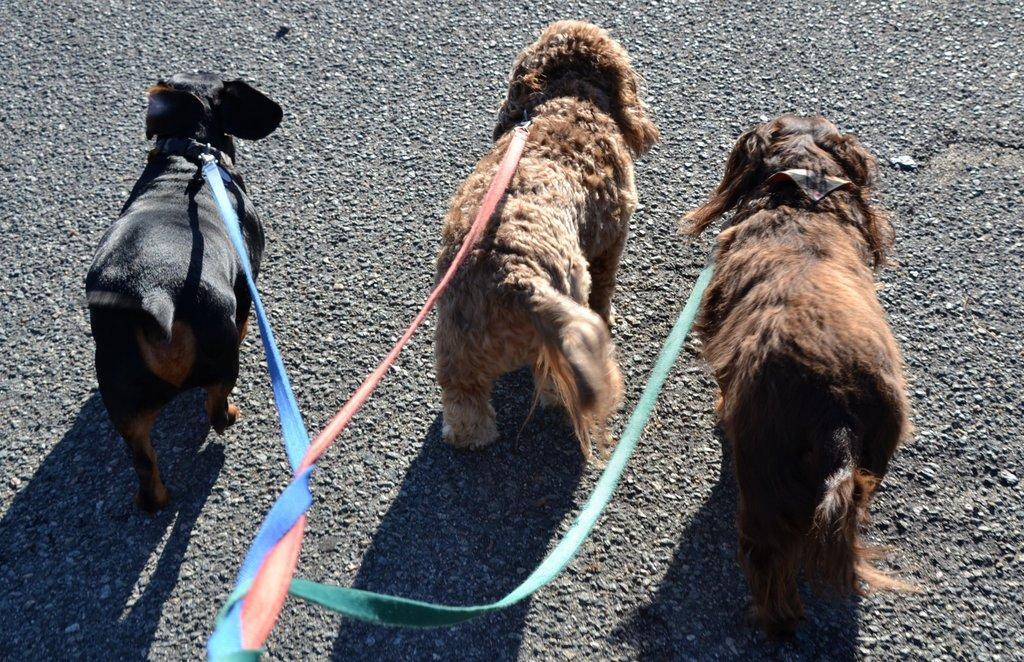Could you give a brief overview of what you see in this image? There is a blue color belt which is tied to the neck of a black color dog which is on the road, orange color belt which is tied to the neck of a brown color dog and green color belt which is tied to the brown color dog and mixed the three belts. In the background, there is black color road. 